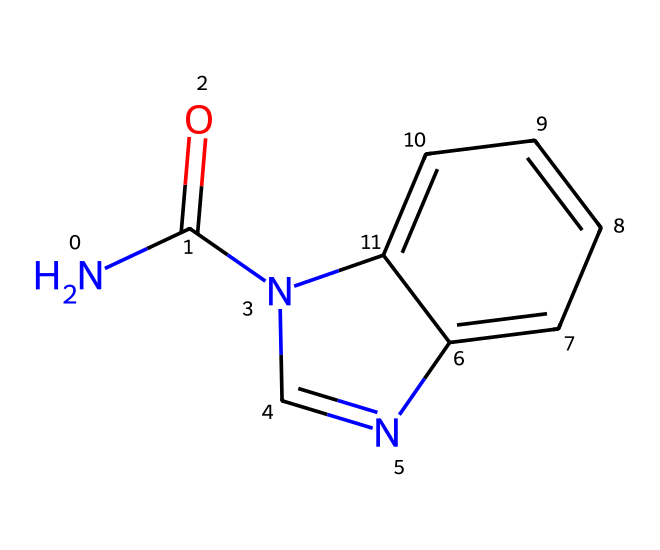What is the molecular formula of carbendazim? To determine the molecular formula from the SMILES representation (NC(=O)N1C=NC2=CC=CC=C21), we identify the types and counts of atoms. We find 9 carbons (C), 9 hydrogens (H), 2 nitrogens (N), and 1 oxygen (O). Thus, the molecular formula is C9H9N2O.
Answer: C9H9N2O How many nitrogen atoms are in the structure? By analyzing the SMILES, we see 'N' appears twice, indicating there are two nitrogen atoms present in the structure.
Answer: 2 What functional groups are present in carbendazim? From the SMILES representation, we identify a carbonyl group (C=O from NC(=O)) and two amide-like structures involving nitrogen (N and adjacent carbon). These indicate the presence of an amide functional group and a potential heterocyclic structure.
Answer: amide What role does the nitrogen atom play in the fungicide's activity? The nitrogen atoms in carbendazim are part of the molecule's structure that contributes to its interaction with biological systems, as nitrogen commonly participates in binding with target enzymes or proteins in fungi, affecting their replication and growth.
Answer: binding How does the chemical structure of carbendazim relate to its fungicidal properties? The ring structure in carbendazim helps it to fit into the active sites of enzymes in fungi, inhibiting processes vital for their survival. Additionally, the amide group increases its solubility and helps in the absorption of the chemical by plants, which is essential for effective fungicidal action.
Answer: ring structure What type of molecular shape does carbendazim exhibit? The arrangement of atoms in carbendazim leads to a planar or slightly twisted molecular shape due to the cyclic components, which facilitate interactions with fungal enzymes effectively.
Answer: planar 